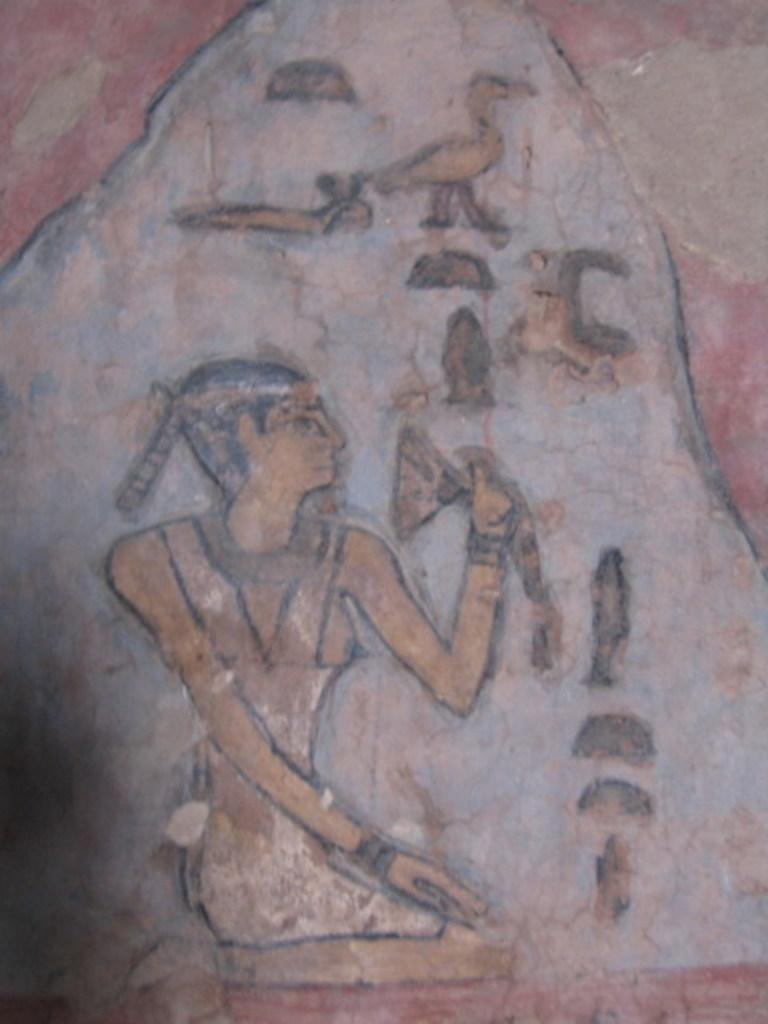What is the main subject in the center of the image? There is an object in the center of the image. What type of drawings are present on the object? The object has a drawing of a person and a drawing of a bird. Are there any other drawings on the object? Yes, the object has drawings of other objects. What type of whip can be seen in the image? There is no whip present in the image. Is there a plate visible in the image? There is no plate visible in the image. 